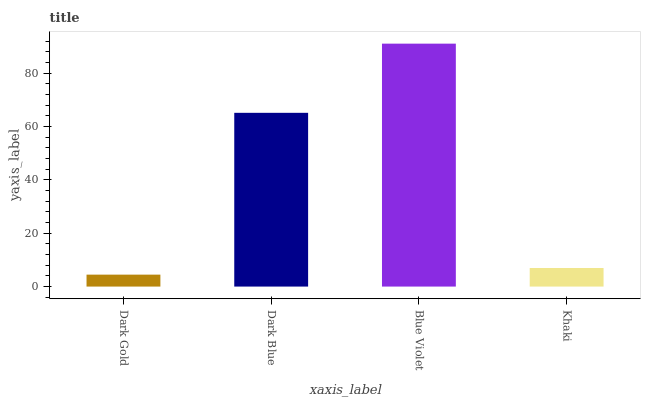Is Dark Gold the minimum?
Answer yes or no. Yes. Is Blue Violet the maximum?
Answer yes or no. Yes. Is Dark Blue the minimum?
Answer yes or no. No. Is Dark Blue the maximum?
Answer yes or no. No. Is Dark Blue greater than Dark Gold?
Answer yes or no. Yes. Is Dark Gold less than Dark Blue?
Answer yes or no. Yes. Is Dark Gold greater than Dark Blue?
Answer yes or no. No. Is Dark Blue less than Dark Gold?
Answer yes or no. No. Is Dark Blue the high median?
Answer yes or no. Yes. Is Khaki the low median?
Answer yes or no. Yes. Is Dark Gold the high median?
Answer yes or no. No. Is Blue Violet the low median?
Answer yes or no. No. 